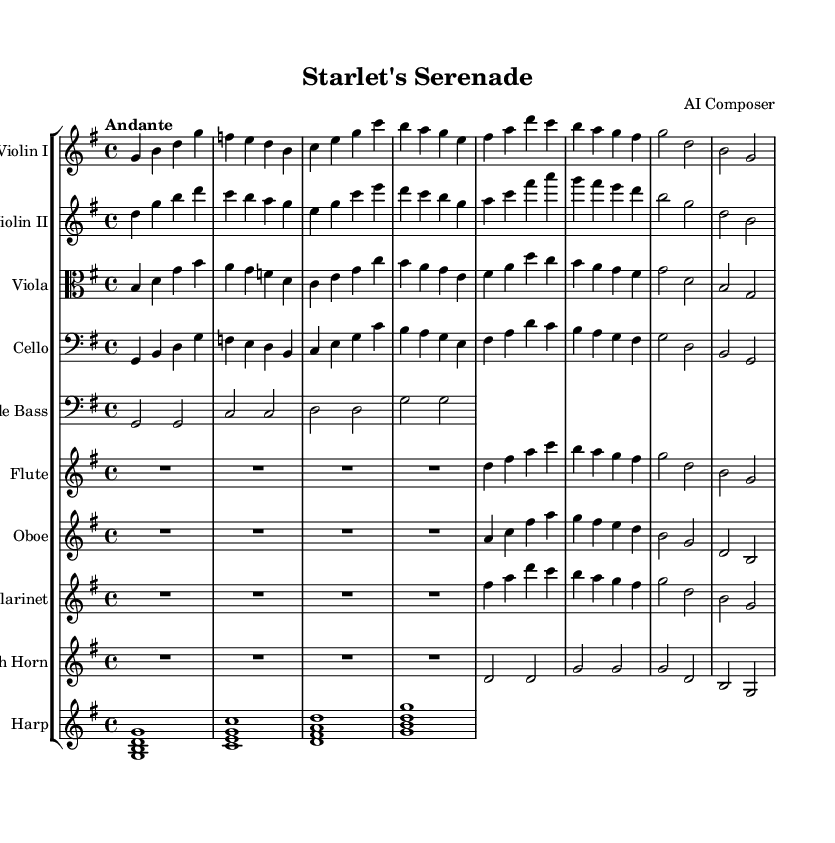What is the key signature of this music? The key signature is indicated by the key signature at the beginning of the music, which shows one sharp in the G major key.
Answer: G major What is the time signature of this music? The time signature is located at the beginning of the sheet music as well; here it shows 4/4 time, meaning there are four beats in each measure.
Answer: 4/4 What is the tempo marking of this music? The tempo marking is given above the staff; in this case, it is marked "Andante," which indicates a moderately slow tempo.
Answer: Andante How many instruments are used in this piece? Count the number of staves in the score; there are ten staves listed, indicating ten different instruments playing in this orchestral piece.
Answer: Ten Which instrument has the melody in the first measure? The first measure shows the first notes played by the first violin staff, indicating that the melody is primarily in the Violin I part.
Answer: Violin I What is the main structure of this theme? By analyzing the notation, it's clear that the piece consists of multiple sections, primarily alternating between melody in the violins and harmonic support from the lower strings and woodwinds, typical of an orchestral theme.
Answer: Orchestral theme Which instrument plays the lowest pitch in this music? Observing the bass clef staff for the Double Bass, this instrument typically plays the lowest notes, which confirms that it provides the foundation of the harmonic structure.
Answer: Double Bass 